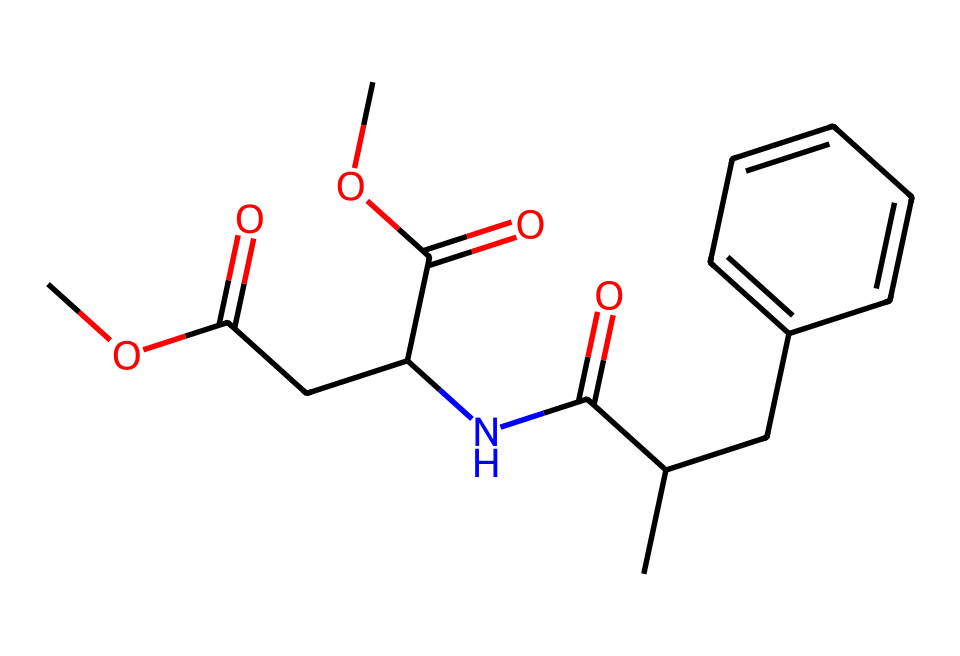What is the primary functional group present in aspartame? Aspartame contains an amide functional group, identified by the nitrogen atom bonded to a carbonyl (C=O) group. This indicates the presence of an amide, as established by the structure.
Answer: amide How many carbon atoms are in aspartame? By counting the carbon atoms in the provided SMILES representation, there are 13 carbon atoms present in total within the whole structure.
Answer: 13 What type of molecule is aspartame classified as? Aspartame is classified as a dipeptide derivative, which is highlighted by the presence of both amino and carboxyl functional groups in its structure. This classifies it accordingly.
Answer: dipeptide What is the total number of rings present in the structure of aspartame? In examining the SMILES notation, there is one aromatic ring indicated by "C1=CC=CC=C1," showing the presence of one ring structure in the molecule.
Answer: 1 What does the presence of ester groups in aspartame indicate? The ester groups, which are formed through the reaction of alcohol and acid, signify that aspartame has sweetening properties, enhancing its effectiveness as a sweetener in food products.
Answer: sweetening properties 